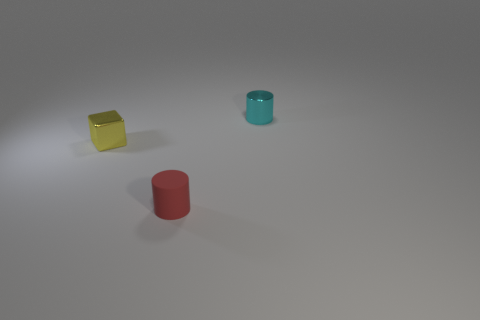Add 2 small cyan rubber balls. How many objects exist? 5 Subtract all cubes. How many objects are left? 2 Add 1 small rubber blocks. How many small rubber blocks exist? 1 Subtract 1 yellow cubes. How many objects are left? 2 Subtract all small yellow shiny things. Subtract all small yellow metal blocks. How many objects are left? 1 Add 3 small red things. How many small red things are left? 4 